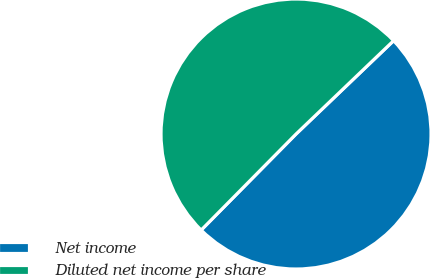<chart> <loc_0><loc_0><loc_500><loc_500><pie_chart><fcel>Net income<fcel>Diluted net income per share<nl><fcel>49.55%<fcel>50.45%<nl></chart> 